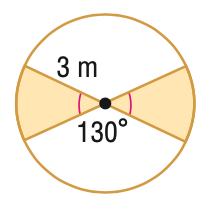Answer the mathemtical geometry problem and directly provide the correct option letter.
Question: Find the area of the shaded region. Round to the nearest tenth.
Choices: A: 3.9 B: 5.2 C: 7.9 D: 20.4 C 